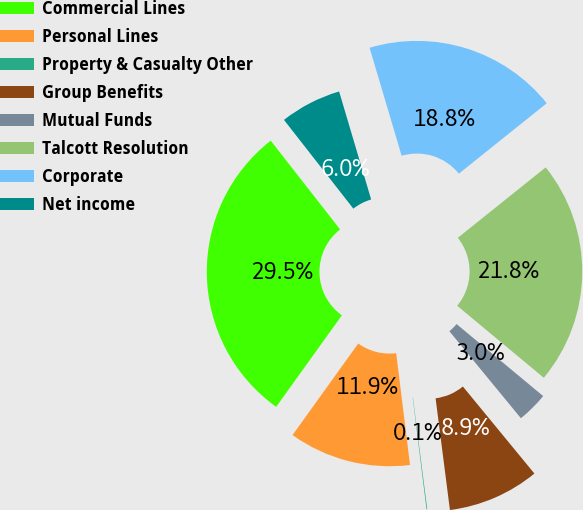Convert chart to OTSL. <chart><loc_0><loc_0><loc_500><loc_500><pie_chart><fcel>Commercial Lines<fcel>Personal Lines<fcel>Property & Casualty Other<fcel>Group Benefits<fcel>Mutual Funds<fcel>Talcott Resolution<fcel>Corporate<fcel>Net income<nl><fcel>29.53%<fcel>11.87%<fcel>0.07%<fcel>8.92%<fcel>3.01%<fcel>21.79%<fcel>18.84%<fcel>5.97%<nl></chart> 